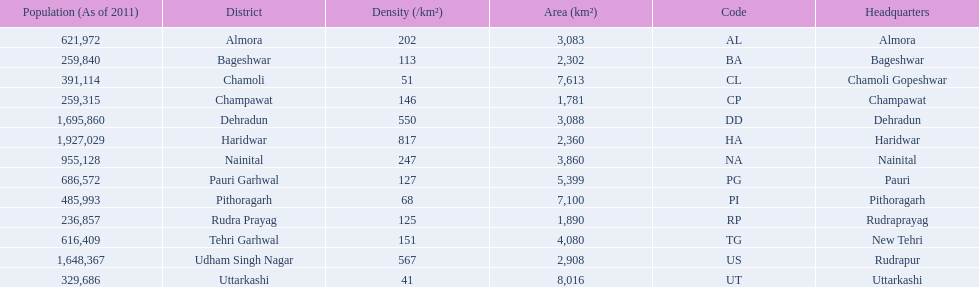What are the names of all the districts? Almora, Bageshwar, Chamoli, Champawat, Dehradun, Haridwar, Nainital, Pauri Garhwal, Pithoragarh, Rudra Prayag, Tehri Garhwal, Udham Singh Nagar, Uttarkashi. What range of densities do these districts encompass? 202, 113, 51, 146, 550, 817, 247, 127, 68, 125, 151, 567, 41. Which district has a density of 51? Chamoli. 